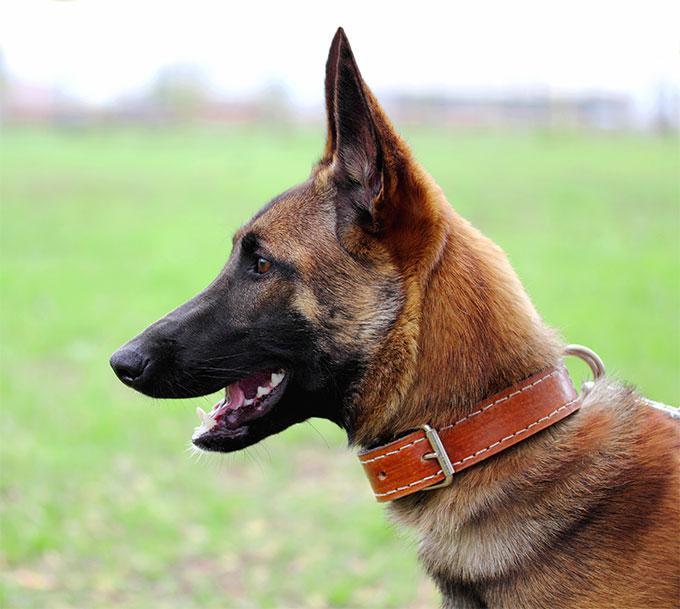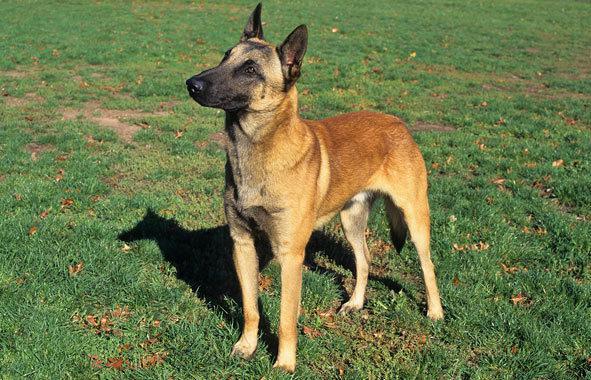The first image is the image on the left, the second image is the image on the right. Given the left and right images, does the statement "At least one dog has a red collar." hold true? Answer yes or no. Yes. 